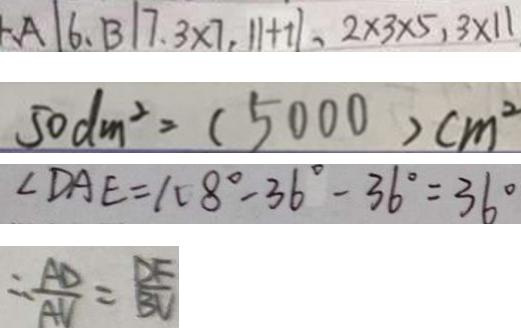Convert formula to latex. <formula><loc_0><loc_0><loc_500><loc_500>A \vert 6 , B \vert 7 . 3 \times 7 , \vert 1 + 1 \vert , 2 \times 3 \times 5 , 3 \times 1 1 
 5 0 d m ^ { 2 } = ( 5 0 0 0 ) c m ^ { 2 } 
 \angle D A E = 1 0 8 ^ { \circ } - 3 6 ^ { \circ } - 3 6 ^ { \circ } = 3 6 ^ { \circ } 
 \therefore \frac { A D } { A V } = \frac { D F } { B V }</formula> 